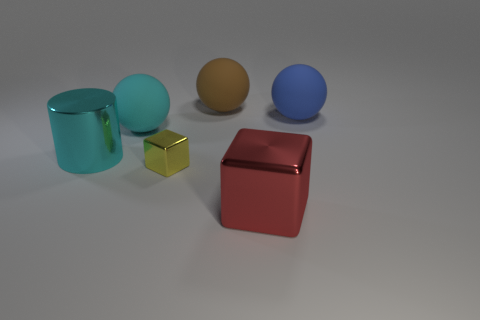Add 4 big brown matte things. How many objects exist? 10 Subtract all blocks. How many objects are left? 4 Add 4 tiny yellow shiny things. How many tiny yellow shiny things are left? 5 Add 2 big cubes. How many big cubes exist? 3 Subtract 0 brown cubes. How many objects are left? 6 Subtract all red cubes. Subtract all matte spheres. How many objects are left? 2 